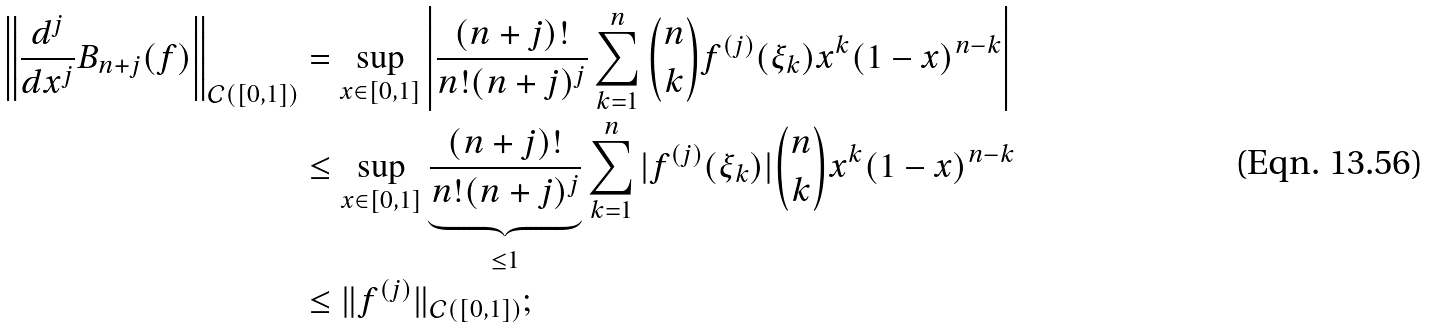<formula> <loc_0><loc_0><loc_500><loc_500>\left \| \frac { d ^ { j } } { d x ^ { j } } B _ { n + j } ( f ) \right \| _ { \mathcal { C } ( [ 0 , 1 ] ) } & = \sup _ { x \in [ 0 , 1 ] } \left | \frac { ( n + j ) ! } { n ! ( n + j ) ^ { j } } \sum _ { k = 1 } ^ { n } \binom { n } { k } f ^ { ( j ) } ( \xi _ { k } ) x ^ { k } ( 1 - x ) ^ { n - k } \right | \\ & \leq \sup _ { x \in [ 0 , 1 ] } \underbrace { \frac { ( n + j ) ! } { n ! ( n + j ) ^ { j } } } _ { \leq 1 } \sum _ { k = 1 } ^ { n } | f ^ { ( j ) } ( \xi _ { k } ) | \binom { n } { k } x ^ { k } ( 1 - x ) ^ { n - k } \\ & \leq \| f ^ { ( j ) } \| _ { \mathcal { C } ( [ 0 , 1 ] ) } ;</formula> 